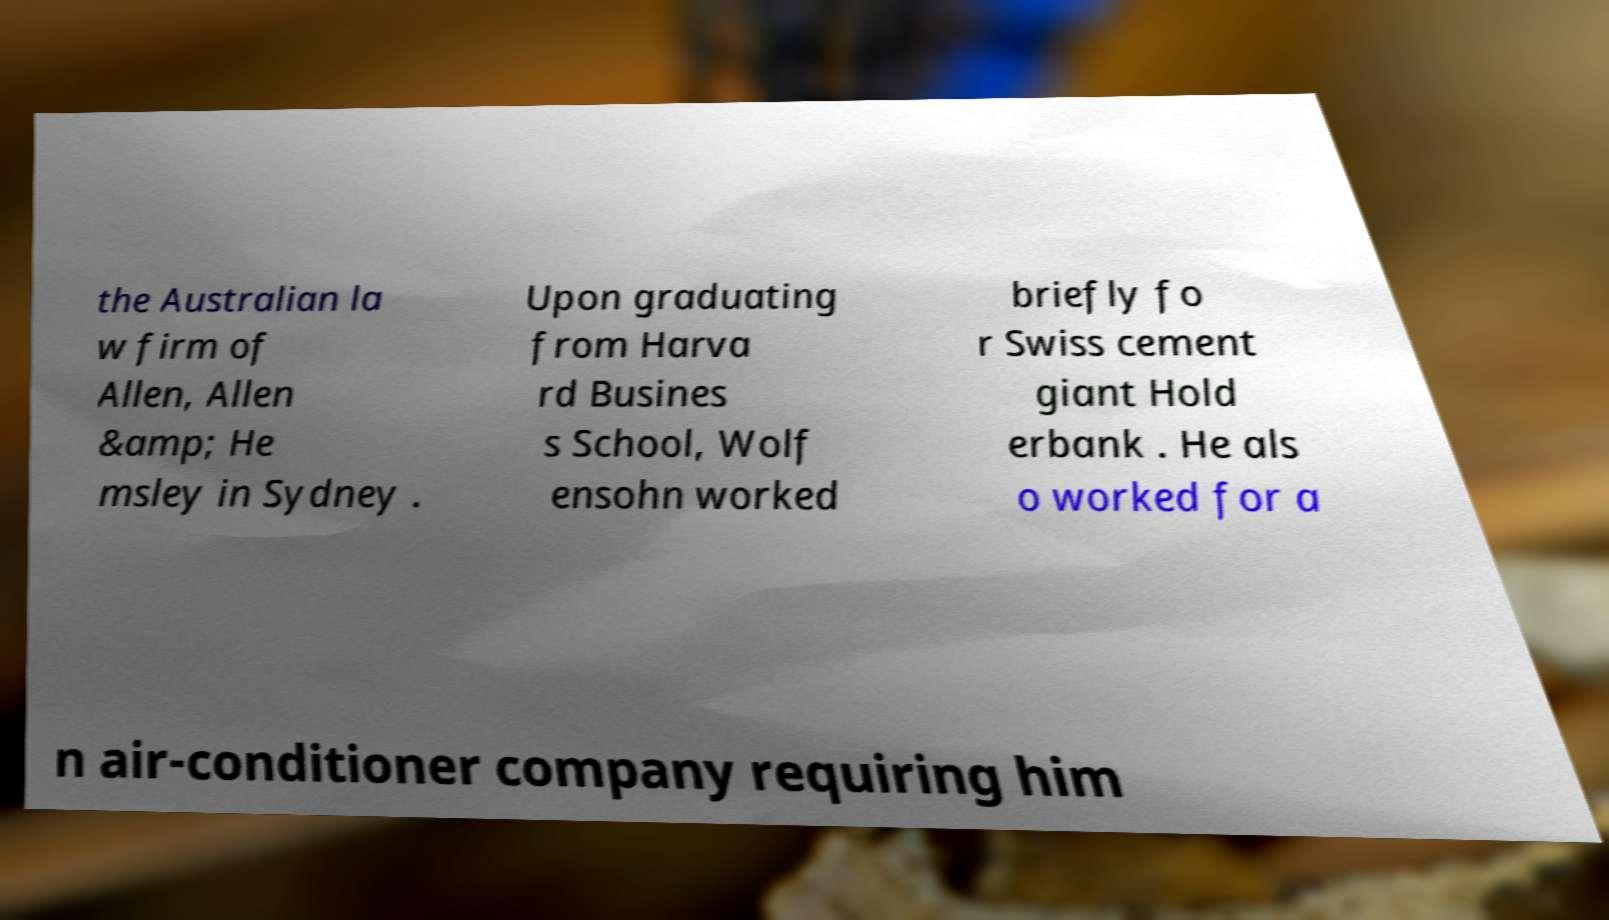Can you accurately transcribe the text from the provided image for me? the Australian la w firm of Allen, Allen &amp; He msley in Sydney . Upon graduating from Harva rd Busines s School, Wolf ensohn worked briefly fo r Swiss cement giant Hold erbank . He als o worked for a n air-conditioner company requiring him 